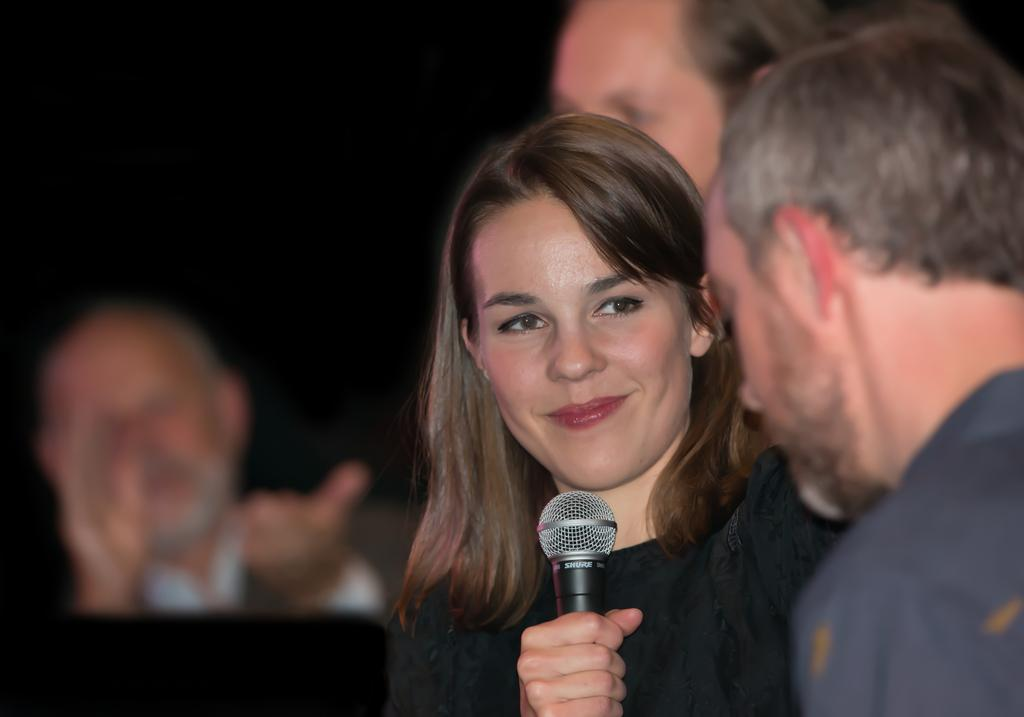Who is the main subject in the image? There is a girl in the image. What is the girl holding in her hand? The girl is holding a mic with her hand. Can you describe the man in the background of the image? The man is in the background of the image, and he is clapping with his hands. What type of flame can be seen coming from the car in the image? There is no car present in the image, so there is no flame to be seen. 